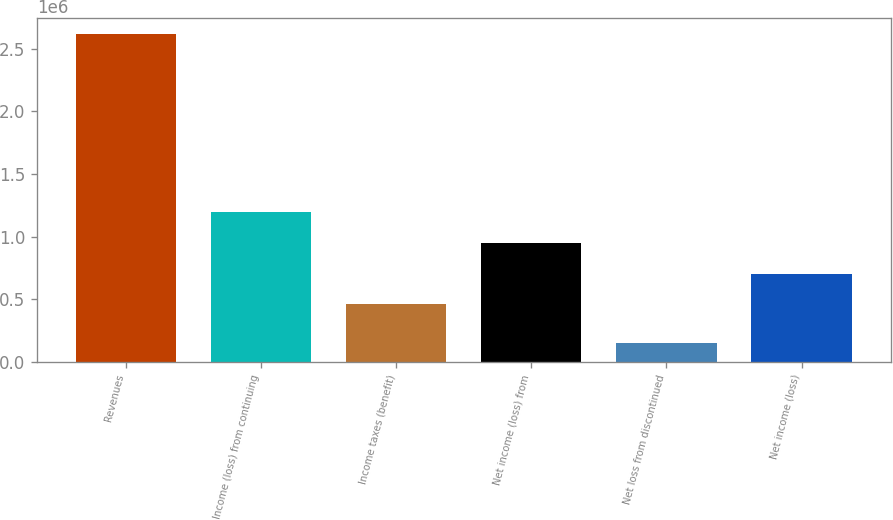<chart> <loc_0><loc_0><loc_500><loc_500><bar_chart><fcel>Revenues<fcel>Income (loss) from continuing<fcel>Income taxes (benefit)<fcel>Net income (loss) from<fcel>Net loss from discontinued<fcel>Net income (loss)<nl><fcel>2.61523e+06<fcel>1.1976e+06<fcel>457298<fcel>950833<fcel>147558<fcel>704066<nl></chart> 